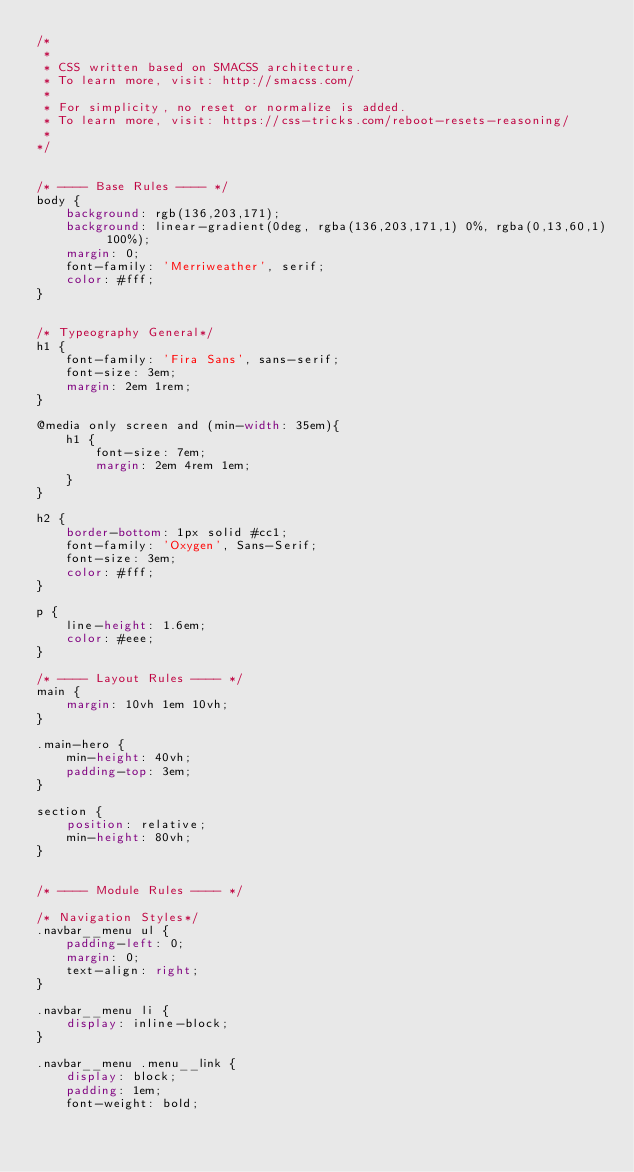Convert code to text. <code><loc_0><loc_0><loc_500><loc_500><_CSS_>/*
 *
 * CSS written based on SMACSS architecture.
 * To learn more, visit: http://smacss.com/
 * 
 * For simplicity, no reset or normalize is added. 
 * To learn more, visit: https://css-tricks.com/reboot-resets-reasoning/
 *
*/


/* ---- Base Rules ---- */
body {
    background: rgb(136,203,171);
    background: linear-gradient(0deg, rgba(136,203,171,1) 0%, rgba(0,13,60,1) 100%);
    margin: 0;
    font-family: 'Merriweather', serif;
    color: #fff;
}


/* Typeography General*/
h1 {
    font-family: 'Fira Sans', sans-serif;
    font-size: 3em;
    margin: 2em 1rem;
}

@media only screen and (min-width: 35em){
    h1 {
        font-size: 7em;
        margin: 2em 4rem 1em;
    }
}

h2 {
    border-bottom: 1px solid #cc1;
    font-family: 'Oxygen', Sans-Serif;
    font-size: 3em;
    color: #fff;
}

p {
    line-height: 1.6em;
    color: #eee;
}

/* ---- Layout Rules ---- */
main {
    margin: 10vh 1em 10vh;
}

.main-hero {
    min-height: 40vh;
    padding-top: 3em;
}

section {
    position: relative;
    min-height: 80vh;
}


/* ---- Module Rules ---- */

/* Navigation Styles*/
.navbar__menu ul {
    padding-left: 0;
    margin: 0;
    text-align: right;
}

.navbar__menu li {
    display: inline-block;
}

.navbar__menu .menu__link {
    display: block;
    padding: 1em;
    font-weight: bold;</code> 